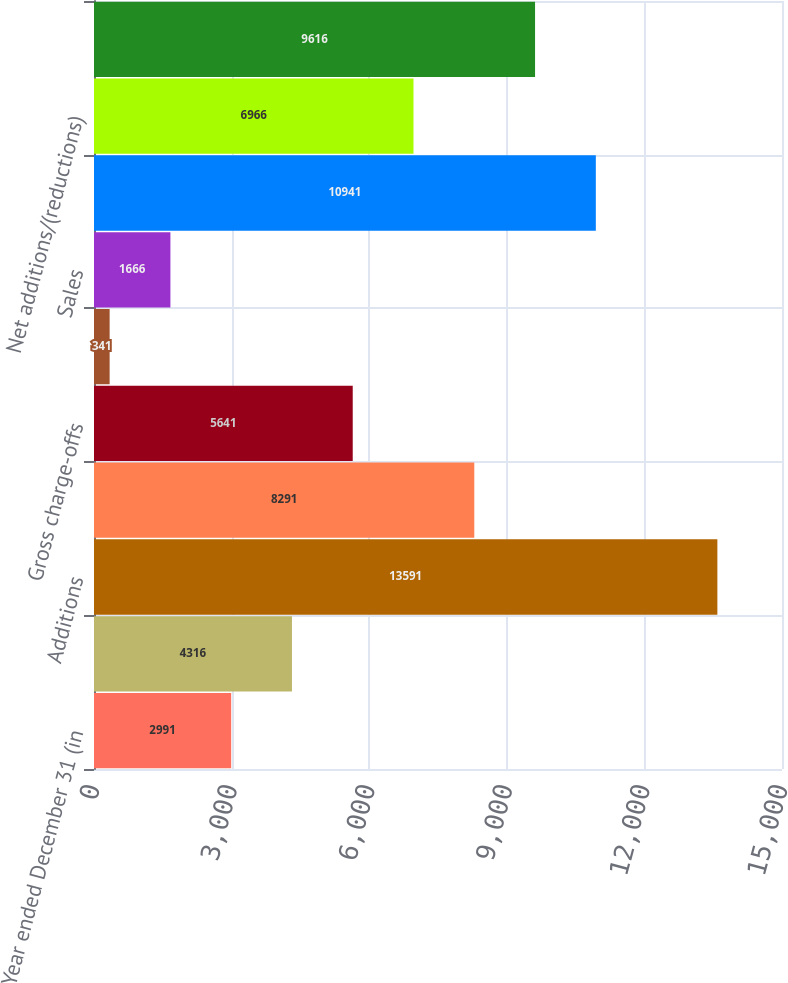Convert chart to OTSL. <chart><loc_0><loc_0><loc_500><loc_500><bar_chart><fcel>Year ended December 31 (in<fcel>Beginning balance<fcel>Additions<fcel>Paydowns and other<fcel>Gross charge-offs<fcel>Returned to performing<fcel>Sales<fcel>Total reductions<fcel>Net additions/(reductions)<fcel>Ending balance<nl><fcel>2991<fcel>4316<fcel>13591<fcel>8291<fcel>5641<fcel>341<fcel>1666<fcel>10941<fcel>6966<fcel>9616<nl></chart> 